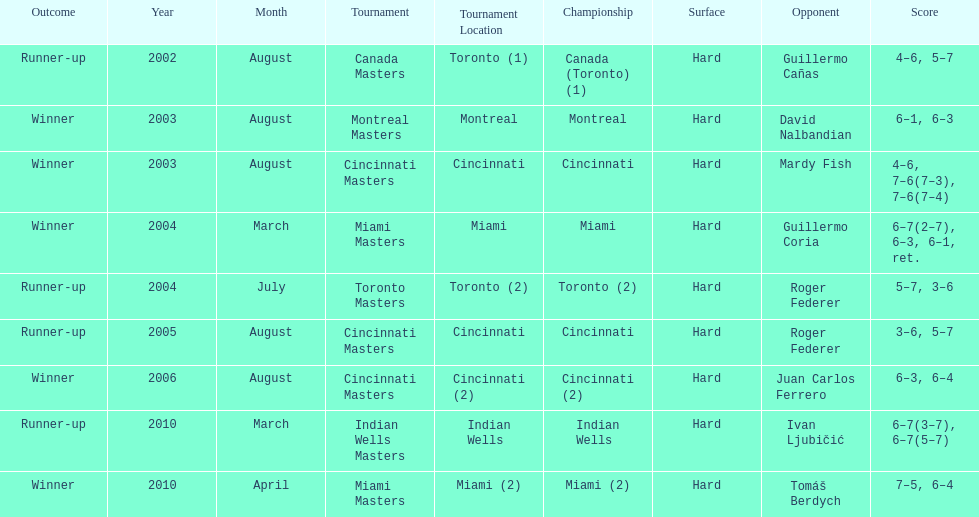How many championships occurred in toronto or montreal? 3. 